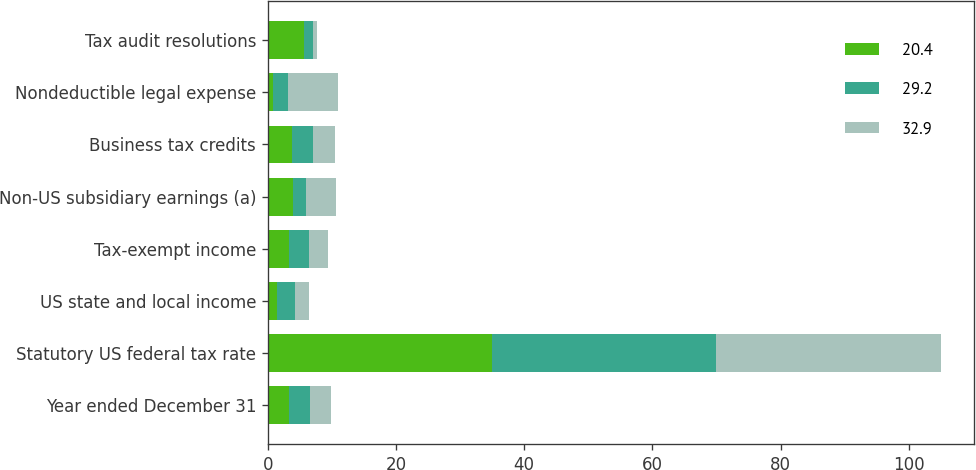Convert chart to OTSL. <chart><loc_0><loc_0><loc_500><loc_500><stacked_bar_chart><ecel><fcel>Year ended December 31<fcel>Statutory US federal tax rate<fcel>US state and local income<fcel>Tax-exempt income<fcel>Non-US subsidiary earnings (a)<fcel>Business tax credits<fcel>Nondeductible legal expense<fcel>Tax audit resolutions<nl><fcel>20.4<fcel>3.3<fcel>35<fcel>1.5<fcel>3.3<fcel>3.9<fcel>3.7<fcel>0.8<fcel>5.7<nl><fcel>29.2<fcel>3.3<fcel>35<fcel>2.7<fcel>3.1<fcel>2<fcel>3.3<fcel>2.3<fcel>1.4<nl><fcel>32.9<fcel>3.3<fcel>35<fcel>2.2<fcel>3<fcel>4.8<fcel>3.4<fcel>7.8<fcel>0.6<nl></chart> 